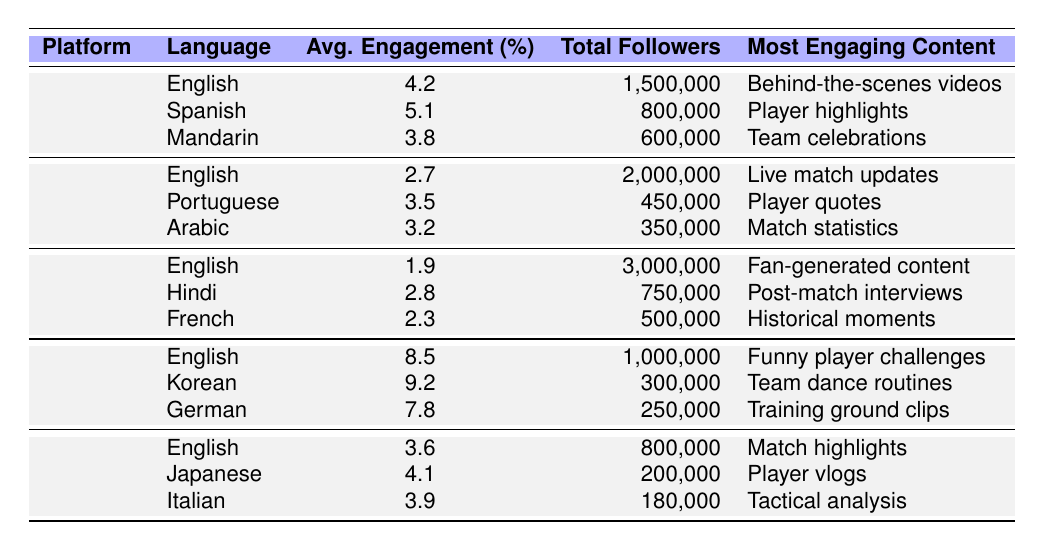What is the average engagement rate for posts in Spanish on Instagram? The table shows that the average engagement rate for Spanish on Instagram is 5.1%.
Answer: 5.1% Which social media platform has the highest average engagement rate for English content? The table indicates that TikTok has the highest average engagement rate for English content at 8.5%.
Answer: TikTok How many total followers does the Portuguese language have on Twitter? Referring to the table, the total followers for Portuguese on Twitter is 450,000.
Answer: 450,000 Is the most engaging content type for Japanese on YouTube related to player vlogs? Yes, the table states that the most engaging content for Japanese on YouTube is indeed player vlogs.
Answer: Yes What is the difference in the average engagement rates between Instagram in Spanish and Mandarin? The average engagement rate for Spanish on Instagram is 5.1%, while for Mandarin it is 3.8%, so the difference is 5.1% - 3.8% = 1.3%.
Answer: 1.3% Which language on Facebook has the highest total followers and what is the number? The table shows that English has the highest total followers on Facebook, with 3,000,000 followers.
Answer: 3,000,000 If we sum the average engagement rates for all languages on TikTok, what is the total? The average engagement rates for TikTok are 8.5% (English), 9.2% (Korean), and 7.8% (German). Summing these gives 8.5% + 9.2% + 7.8% = 25.5%.
Answer: 25.5% What content type engages the most on Instagram in English? The table indicates that the most engaging content type for English on Instagram is behind-the-scenes videos.
Answer: Behind-the-scenes videos Is the average engagement rate higher for Facebook content in Hindi than for Twitter content in Arabic? Yes, Hindi on Facebook has an average engagement rate of 2.8%, which is higher than Arabic on Twitter, which is 3.2%. However, since we are comparing rates, it should be noted that Hindi < Arabic.
Answer: No What is the most engaging content type for the highest engagement rate language across any platform? The highest engagement rate is for Korean on TikTok at 9.2%, and the most engaging content type is team dance routines.
Answer: Team dance routines 